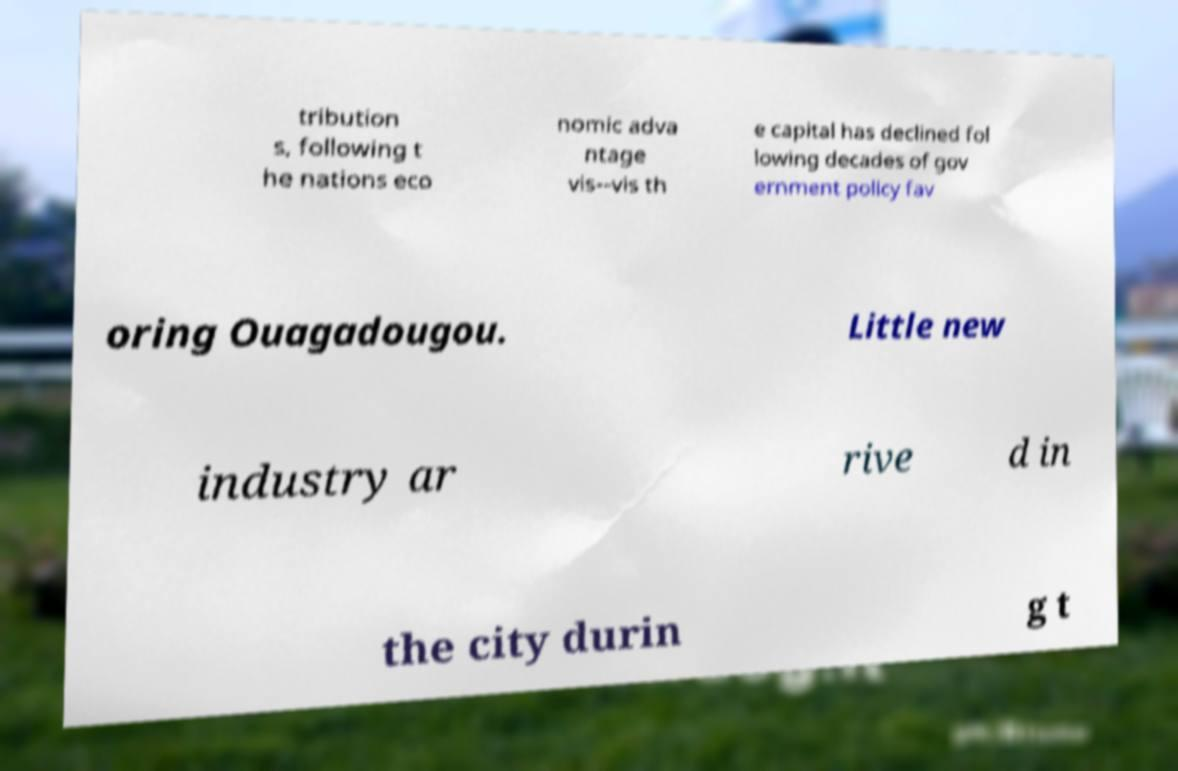Could you assist in decoding the text presented in this image and type it out clearly? tribution s, following t he nations eco nomic adva ntage vis--vis th e capital has declined fol lowing decades of gov ernment policy fav oring Ouagadougou. Little new industry ar rive d in the city durin g t 